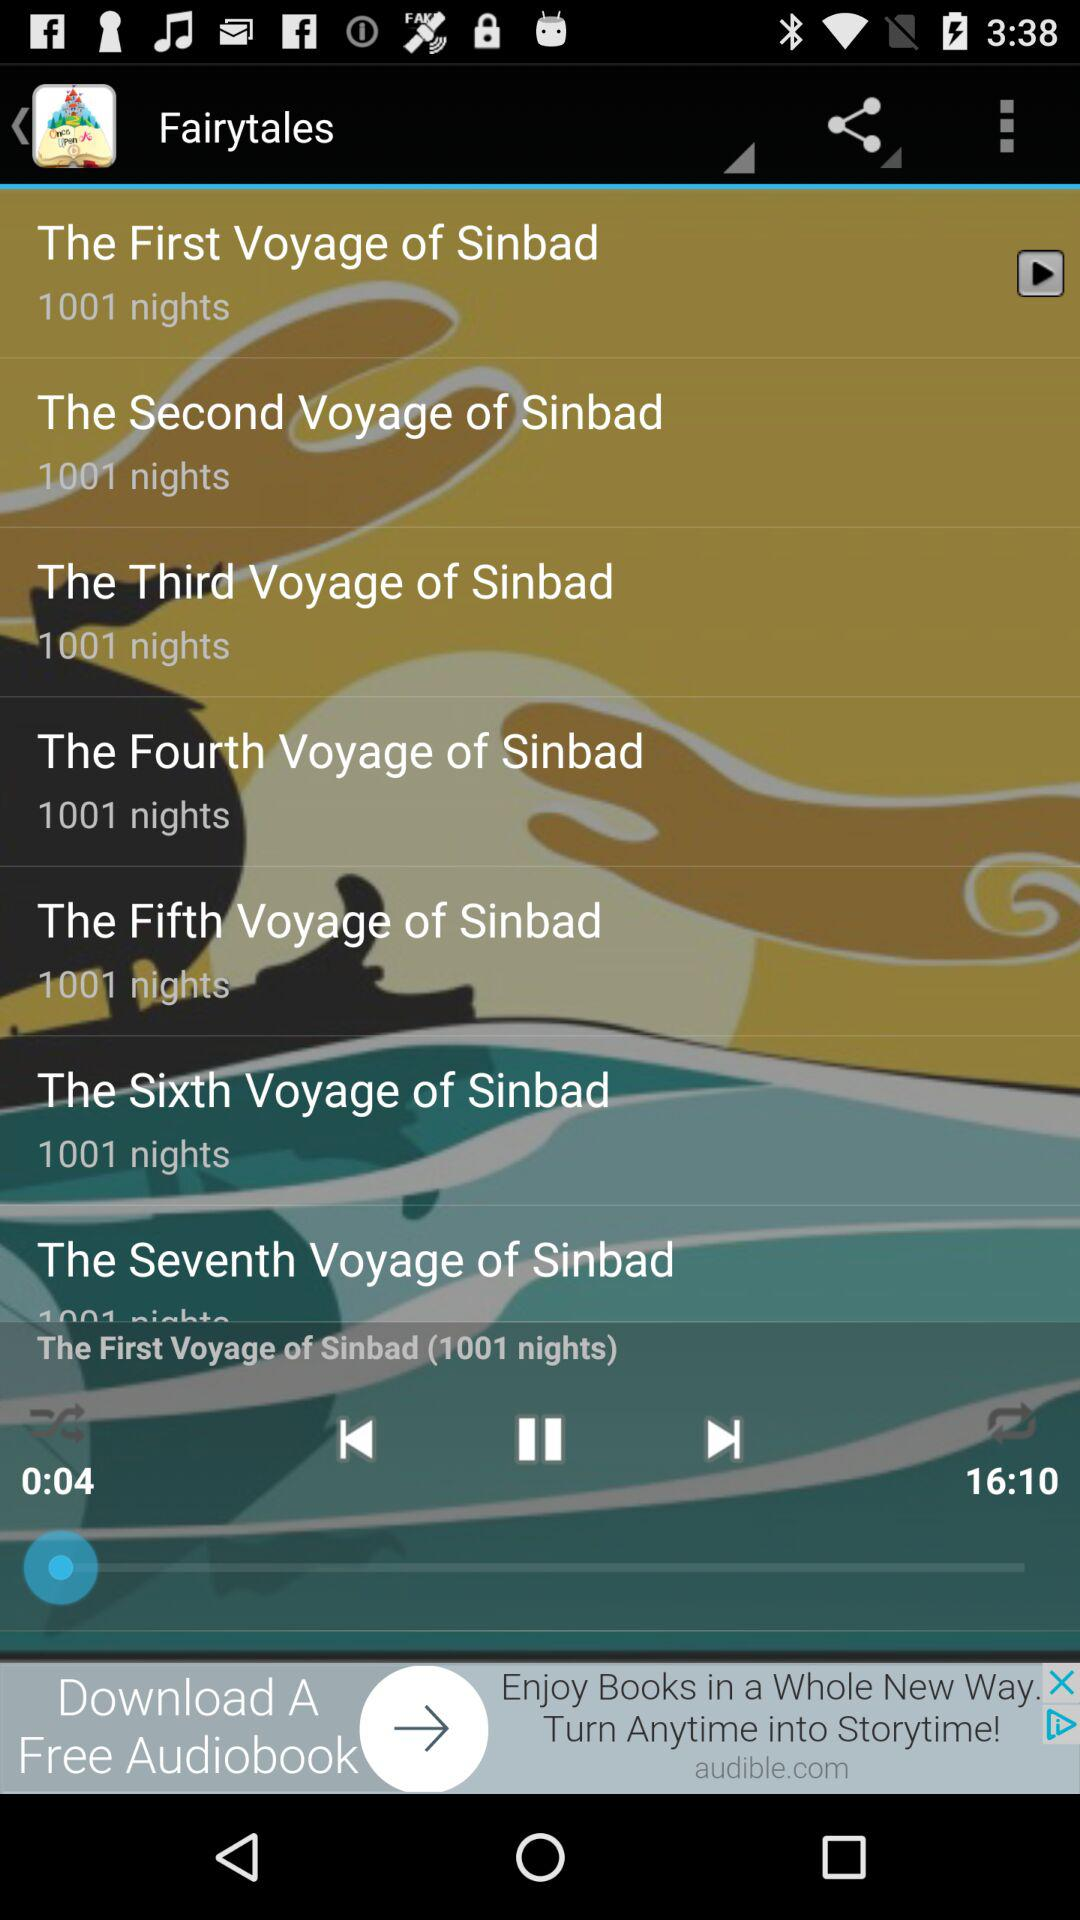Define the name of album?
When the provided information is insufficient, respond with <no answer>. <no answer> 